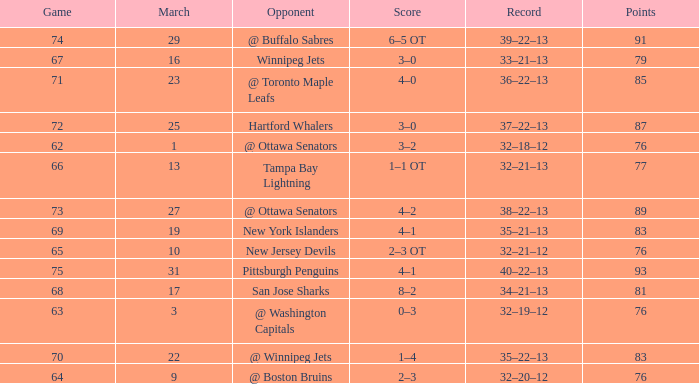Which Game is the lowest one that has a Score of 2–3 ot, and Points larger than 76? None. 